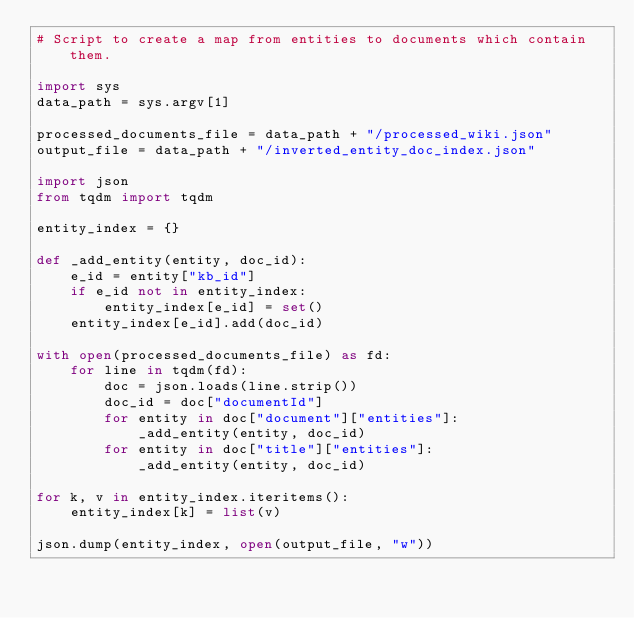<code> <loc_0><loc_0><loc_500><loc_500><_Python_># Script to create a map from entities to documents which contain them.

import sys
data_path = sys.argv[1]

processed_documents_file = data_path + "/processed_wiki.json"
output_file = data_path + "/inverted_entity_doc_index.json"

import json
from tqdm import tqdm

entity_index = {}

def _add_entity(entity, doc_id):
    e_id = entity["kb_id"]
    if e_id not in entity_index:
        entity_index[e_id] = set()
    entity_index[e_id].add(doc_id)

with open(processed_documents_file) as fd:
    for line in tqdm(fd):
        doc = json.loads(line.strip())
        doc_id = doc["documentId"]
        for entity in doc["document"]["entities"]:
            _add_entity(entity, doc_id)
        for entity in doc["title"]["entities"]:
            _add_entity(entity, doc_id)

for k, v in entity_index.iteritems():
    entity_index[k] = list(v)

json.dump(entity_index, open(output_file, "w"))
</code> 